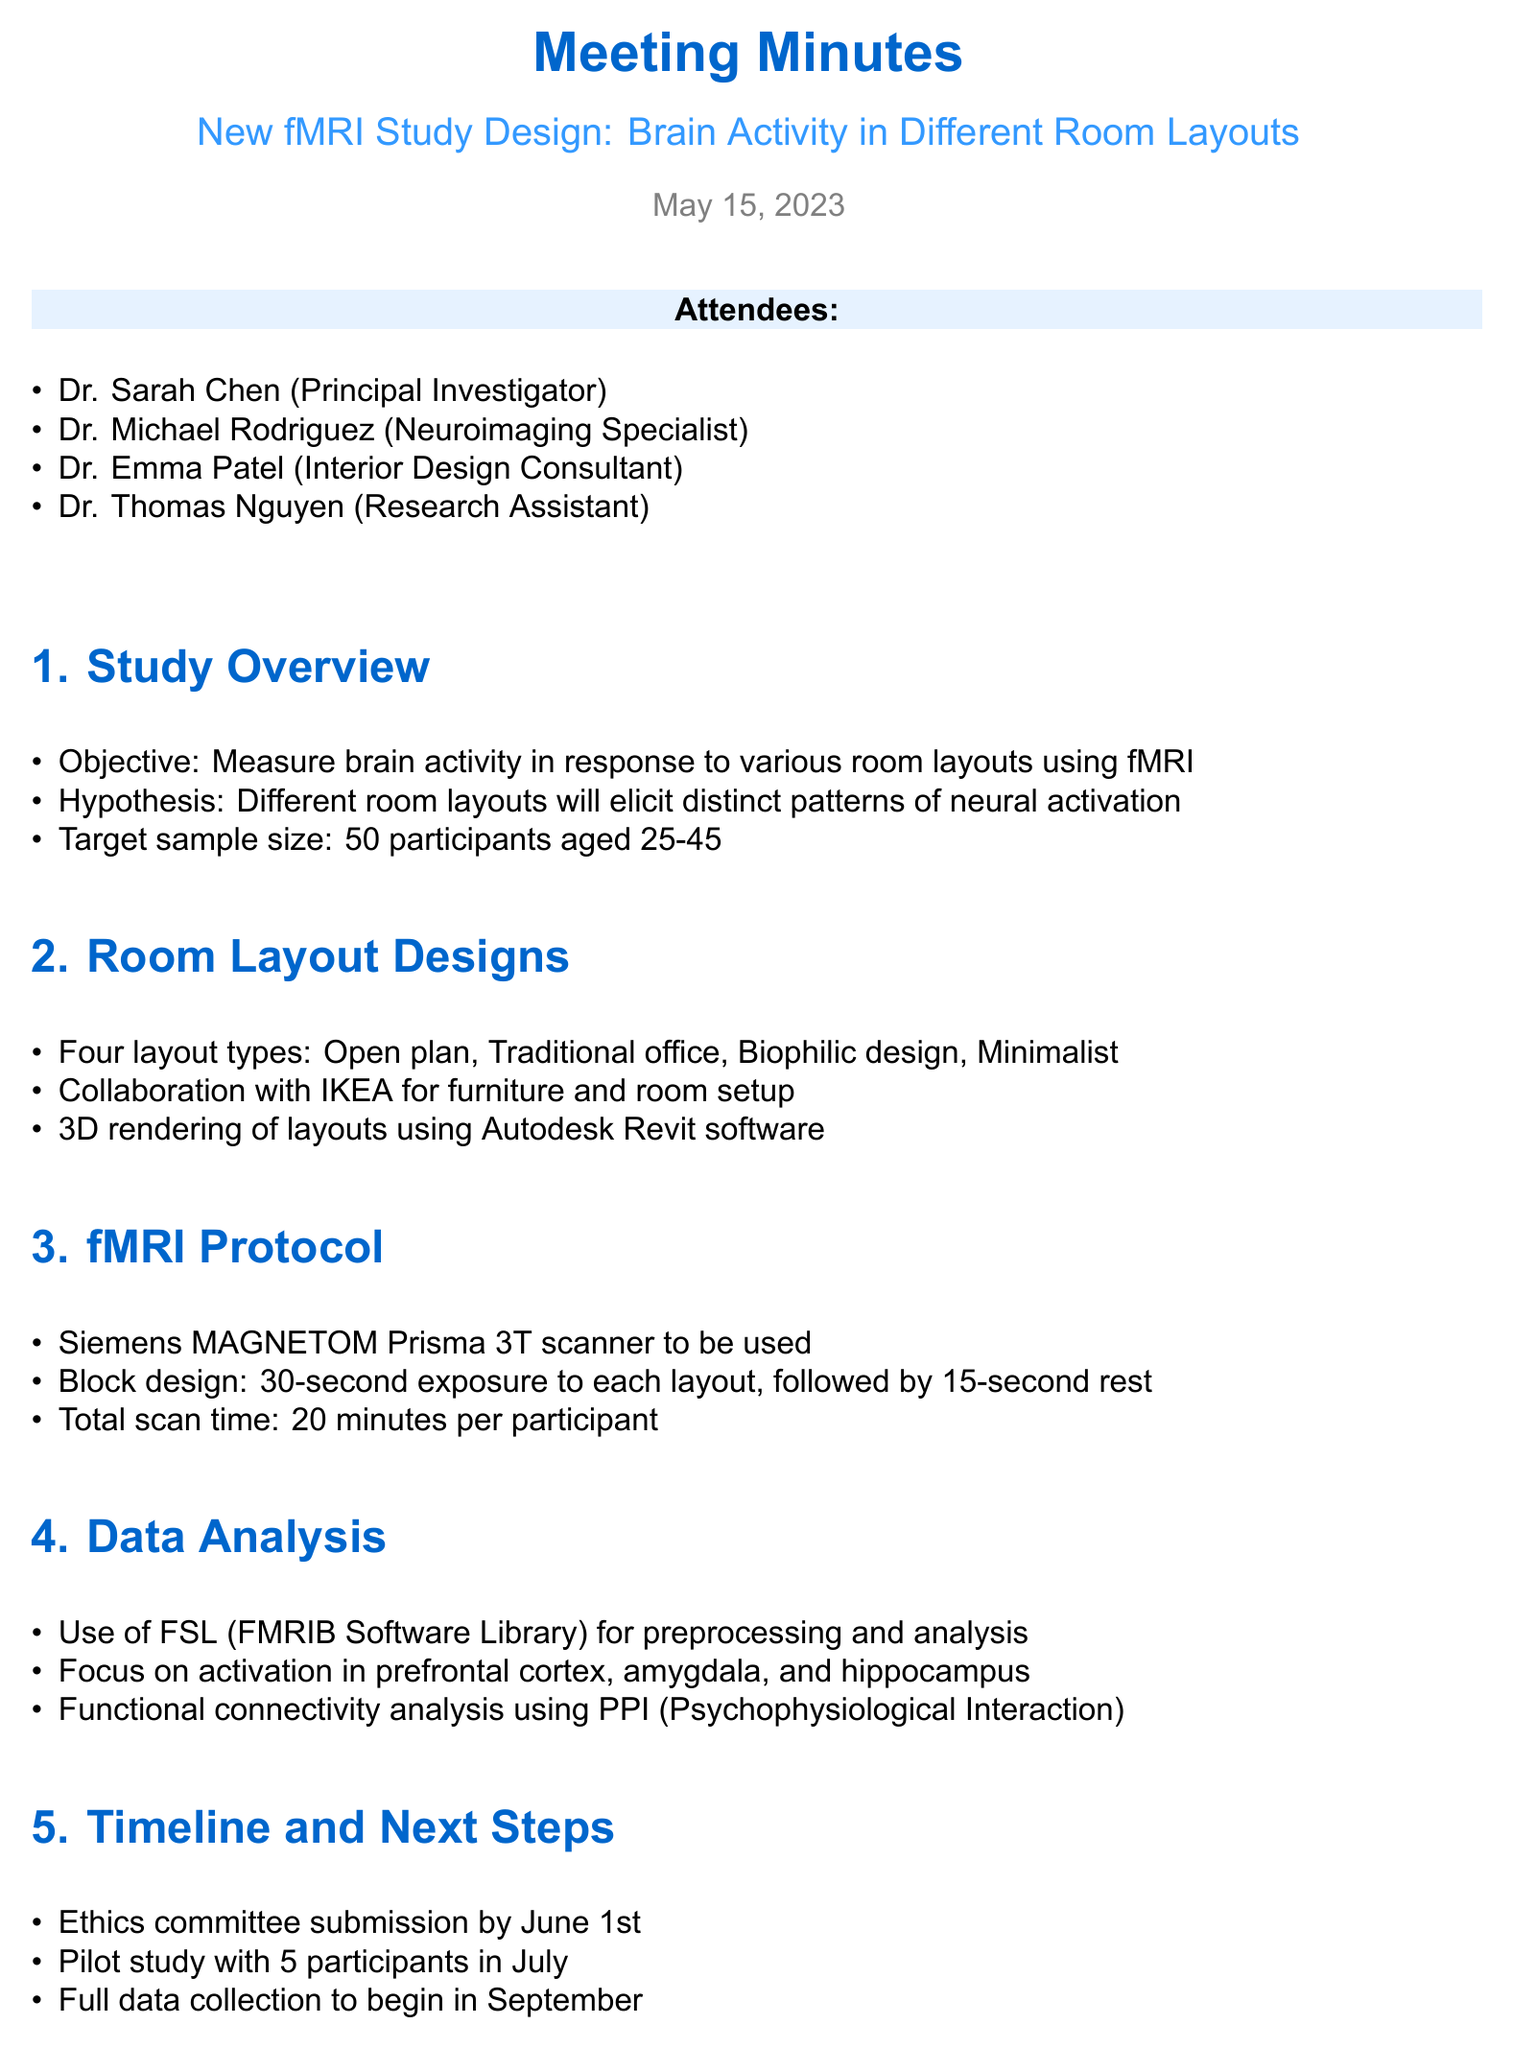What is the study's objective? The objective is to measure brain activity in response to various room layouts using fMRI.
Answer: Measure brain activity in response to various room layouts using fMRI What is the target sample size? The target sample size mentioned in the document is for 50 participants.
Answer: 50 participants Who is the interior design consultant? The document lists Dr. Emma Patel as the interior design consultant attending the meeting.
Answer: Dr. Emma Patel Which fMRI scanner will be used? The document specifies the use of the Siemens MAGNETOM Prisma 3T scanner for the study.
Answer: Siemens MAGNETOM Prisma 3T When is the ethics committee submission due? The timeline states that the ethics committee submission is due by June 1st.
Answer: June 1st What types of room layouts are being tested? The document lists four room layout types: Open plan, Traditional office, Biophilic design, and Minimalist.
Answer: Open plan, Traditional office, Biophilic design, Minimalist How long will each participant's scan take? According to the protocol, the total scan time for each participant is specified as 20 minutes.
Answer: 20 minutes What software will be used for 3D rendering? The meeting minutes indicate that Autodesk Revit software will be used for creating 3D renderings of the layouts.
Answer: Autodesk Revit What is the next step after the pilot study? The full data collection is scheduled to begin in September following the pilot study in July.
Answer: Full data collection in September What analysis software will be used? The document states that FSL (FMRIB Software Library) will be used for preprocessing and analysis of the data.
Answer: FSL (FMRIB Software Library) 